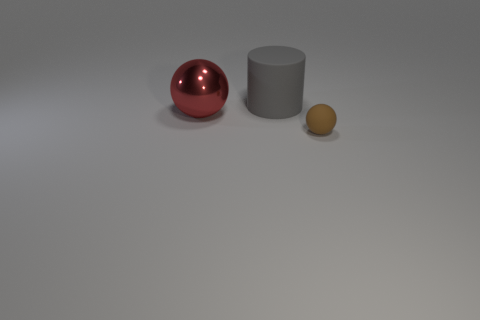Are the large red object and the brown thing made of the same material?
Give a very brief answer. No. There is a object that is on the right side of the thing that is behind the large metallic sphere; what is it made of?
Ensure brevity in your answer.  Rubber. Is the number of objects that are on the left side of the brown matte sphere greater than the number of small gray rubber balls?
Your answer should be compact. Yes. How many other things are the same size as the brown matte thing?
Ensure brevity in your answer.  0. Is the big shiny thing the same color as the rubber cylinder?
Keep it short and to the point. No. The sphere behind the object right of the matte object that is on the left side of the brown object is what color?
Keep it short and to the point. Red. What number of red balls are right of the object right of the big object behind the shiny sphere?
Your response must be concise. 0. Is there anything else that is the same color as the small rubber ball?
Your answer should be compact. No. There is a rubber thing that is to the left of the brown object; is its size the same as the small brown rubber sphere?
Ensure brevity in your answer.  No. What number of spheres are behind the object to the right of the big gray cylinder?
Your answer should be compact. 1. 